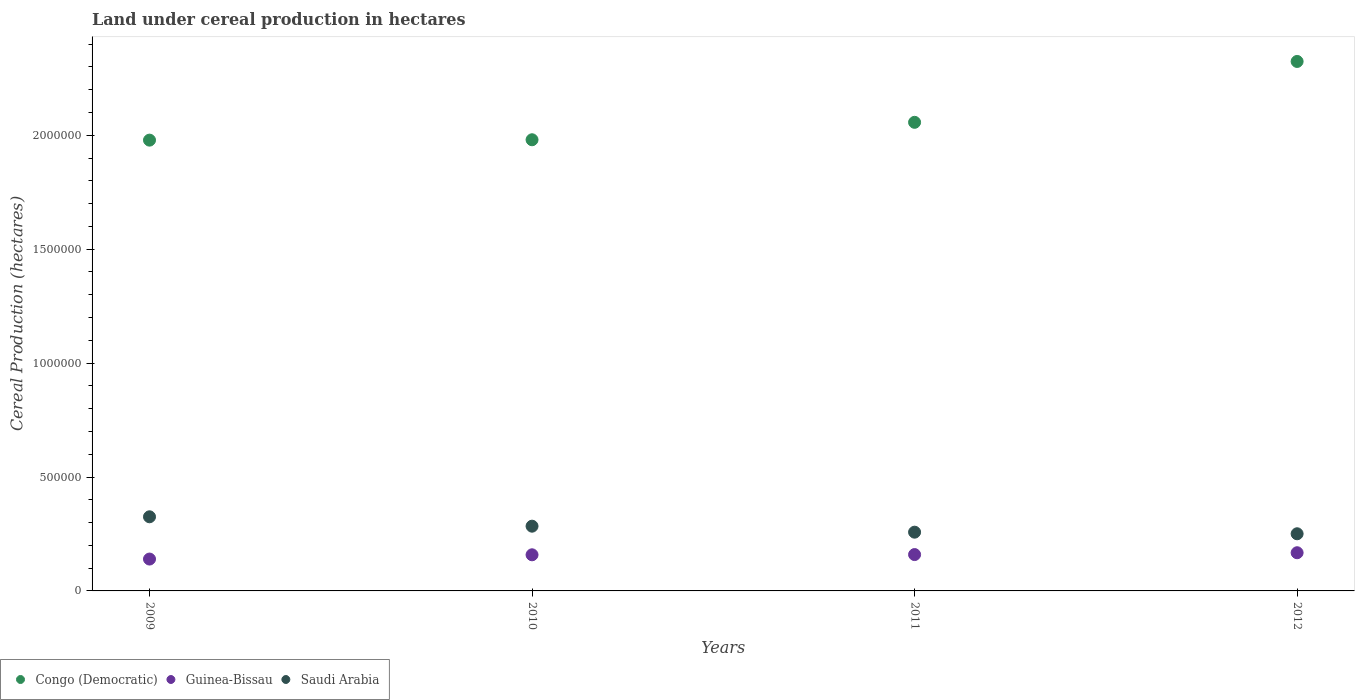Is the number of dotlines equal to the number of legend labels?
Make the answer very short. Yes. What is the land under cereal production in Congo (Democratic) in 2009?
Your response must be concise. 1.98e+06. Across all years, what is the maximum land under cereal production in Saudi Arabia?
Your response must be concise. 3.25e+05. Across all years, what is the minimum land under cereal production in Guinea-Bissau?
Your response must be concise. 1.40e+05. What is the total land under cereal production in Congo (Democratic) in the graph?
Make the answer very short. 8.34e+06. What is the difference between the land under cereal production in Congo (Democratic) in 2010 and that in 2012?
Your response must be concise. -3.44e+05. What is the difference between the land under cereal production in Congo (Democratic) in 2011 and the land under cereal production in Saudi Arabia in 2010?
Provide a succinct answer. 1.77e+06. What is the average land under cereal production in Guinea-Bissau per year?
Offer a terse response. 1.56e+05. In the year 2011, what is the difference between the land under cereal production in Guinea-Bissau and land under cereal production in Saudi Arabia?
Keep it short and to the point. -9.83e+04. What is the ratio of the land under cereal production in Guinea-Bissau in 2011 to that in 2012?
Your answer should be compact. 0.95. What is the difference between the highest and the second highest land under cereal production in Saudi Arabia?
Give a very brief answer. 4.12e+04. What is the difference between the highest and the lowest land under cereal production in Congo (Democratic)?
Offer a terse response. 3.45e+05. In how many years, is the land under cereal production in Saudi Arabia greater than the average land under cereal production in Saudi Arabia taken over all years?
Ensure brevity in your answer.  2. Is the sum of the land under cereal production in Congo (Democratic) in 2010 and 2012 greater than the maximum land under cereal production in Saudi Arabia across all years?
Your answer should be very brief. Yes. Does the land under cereal production in Congo (Democratic) monotonically increase over the years?
Give a very brief answer. Yes. How many dotlines are there?
Ensure brevity in your answer.  3. Are the values on the major ticks of Y-axis written in scientific E-notation?
Provide a succinct answer. No. Does the graph contain grids?
Offer a terse response. No. Where does the legend appear in the graph?
Ensure brevity in your answer.  Bottom left. How are the legend labels stacked?
Offer a terse response. Horizontal. What is the title of the graph?
Your answer should be very brief. Land under cereal production in hectares. Does "Cyprus" appear as one of the legend labels in the graph?
Ensure brevity in your answer.  No. What is the label or title of the Y-axis?
Give a very brief answer. Cereal Production (hectares). What is the Cereal Production (hectares) in Congo (Democratic) in 2009?
Provide a short and direct response. 1.98e+06. What is the Cereal Production (hectares) of Guinea-Bissau in 2009?
Make the answer very short. 1.40e+05. What is the Cereal Production (hectares) in Saudi Arabia in 2009?
Your answer should be compact. 3.25e+05. What is the Cereal Production (hectares) of Congo (Democratic) in 2010?
Ensure brevity in your answer.  1.98e+06. What is the Cereal Production (hectares) of Guinea-Bissau in 2010?
Offer a terse response. 1.59e+05. What is the Cereal Production (hectares) in Saudi Arabia in 2010?
Offer a terse response. 2.84e+05. What is the Cereal Production (hectares) of Congo (Democratic) in 2011?
Give a very brief answer. 2.06e+06. What is the Cereal Production (hectares) in Guinea-Bissau in 2011?
Offer a terse response. 1.60e+05. What is the Cereal Production (hectares) in Saudi Arabia in 2011?
Offer a very short reply. 2.58e+05. What is the Cereal Production (hectares) of Congo (Democratic) in 2012?
Your answer should be compact. 2.32e+06. What is the Cereal Production (hectares) in Guinea-Bissau in 2012?
Ensure brevity in your answer.  1.68e+05. What is the Cereal Production (hectares) of Saudi Arabia in 2012?
Keep it short and to the point. 2.51e+05. Across all years, what is the maximum Cereal Production (hectares) in Congo (Democratic)?
Provide a succinct answer. 2.32e+06. Across all years, what is the maximum Cereal Production (hectares) in Guinea-Bissau?
Give a very brief answer. 1.68e+05. Across all years, what is the maximum Cereal Production (hectares) of Saudi Arabia?
Offer a very short reply. 3.25e+05. Across all years, what is the minimum Cereal Production (hectares) in Congo (Democratic)?
Offer a terse response. 1.98e+06. Across all years, what is the minimum Cereal Production (hectares) of Guinea-Bissau?
Ensure brevity in your answer.  1.40e+05. Across all years, what is the minimum Cereal Production (hectares) of Saudi Arabia?
Make the answer very short. 2.51e+05. What is the total Cereal Production (hectares) of Congo (Democratic) in the graph?
Keep it short and to the point. 8.34e+06. What is the total Cereal Production (hectares) in Guinea-Bissau in the graph?
Make the answer very short. 6.26e+05. What is the total Cereal Production (hectares) of Saudi Arabia in the graph?
Provide a succinct answer. 1.12e+06. What is the difference between the Cereal Production (hectares) in Congo (Democratic) in 2009 and that in 2010?
Your answer should be compact. -1632. What is the difference between the Cereal Production (hectares) of Guinea-Bissau in 2009 and that in 2010?
Give a very brief answer. -1.87e+04. What is the difference between the Cereal Production (hectares) in Saudi Arabia in 2009 and that in 2010?
Offer a terse response. 4.12e+04. What is the difference between the Cereal Production (hectares) of Congo (Democratic) in 2009 and that in 2011?
Your answer should be compact. -7.82e+04. What is the difference between the Cereal Production (hectares) in Guinea-Bissau in 2009 and that in 2011?
Ensure brevity in your answer.  -1.97e+04. What is the difference between the Cereal Production (hectares) in Saudi Arabia in 2009 and that in 2011?
Give a very brief answer. 6.75e+04. What is the difference between the Cereal Production (hectares) of Congo (Democratic) in 2009 and that in 2012?
Ensure brevity in your answer.  -3.45e+05. What is the difference between the Cereal Production (hectares) in Guinea-Bissau in 2009 and that in 2012?
Ensure brevity in your answer.  -2.78e+04. What is the difference between the Cereal Production (hectares) of Saudi Arabia in 2009 and that in 2012?
Ensure brevity in your answer.  7.45e+04. What is the difference between the Cereal Production (hectares) in Congo (Democratic) in 2010 and that in 2011?
Offer a terse response. -7.66e+04. What is the difference between the Cereal Production (hectares) of Guinea-Bissau in 2010 and that in 2011?
Make the answer very short. -995. What is the difference between the Cereal Production (hectares) in Saudi Arabia in 2010 and that in 2011?
Give a very brief answer. 2.63e+04. What is the difference between the Cereal Production (hectares) in Congo (Democratic) in 2010 and that in 2012?
Provide a succinct answer. -3.44e+05. What is the difference between the Cereal Production (hectares) of Guinea-Bissau in 2010 and that in 2012?
Keep it short and to the point. -9051. What is the difference between the Cereal Production (hectares) of Saudi Arabia in 2010 and that in 2012?
Offer a very short reply. 3.33e+04. What is the difference between the Cereal Production (hectares) in Congo (Democratic) in 2011 and that in 2012?
Your answer should be very brief. -2.67e+05. What is the difference between the Cereal Production (hectares) in Guinea-Bissau in 2011 and that in 2012?
Give a very brief answer. -8056. What is the difference between the Cereal Production (hectares) of Saudi Arabia in 2011 and that in 2012?
Keep it short and to the point. 7025. What is the difference between the Cereal Production (hectares) in Congo (Democratic) in 2009 and the Cereal Production (hectares) in Guinea-Bissau in 2010?
Provide a succinct answer. 1.82e+06. What is the difference between the Cereal Production (hectares) of Congo (Democratic) in 2009 and the Cereal Production (hectares) of Saudi Arabia in 2010?
Ensure brevity in your answer.  1.69e+06. What is the difference between the Cereal Production (hectares) of Guinea-Bissau in 2009 and the Cereal Production (hectares) of Saudi Arabia in 2010?
Give a very brief answer. -1.44e+05. What is the difference between the Cereal Production (hectares) of Congo (Democratic) in 2009 and the Cereal Production (hectares) of Guinea-Bissau in 2011?
Offer a very short reply. 1.82e+06. What is the difference between the Cereal Production (hectares) in Congo (Democratic) in 2009 and the Cereal Production (hectares) in Saudi Arabia in 2011?
Give a very brief answer. 1.72e+06. What is the difference between the Cereal Production (hectares) of Guinea-Bissau in 2009 and the Cereal Production (hectares) of Saudi Arabia in 2011?
Ensure brevity in your answer.  -1.18e+05. What is the difference between the Cereal Production (hectares) of Congo (Democratic) in 2009 and the Cereal Production (hectares) of Guinea-Bissau in 2012?
Offer a terse response. 1.81e+06. What is the difference between the Cereal Production (hectares) of Congo (Democratic) in 2009 and the Cereal Production (hectares) of Saudi Arabia in 2012?
Your answer should be compact. 1.73e+06. What is the difference between the Cereal Production (hectares) in Guinea-Bissau in 2009 and the Cereal Production (hectares) in Saudi Arabia in 2012?
Your answer should be compact. -1.11e+05. What is the difference between the Cereal Production (hectares) of Congo (Democratic) in 2010 and the Cereal Production (hectares) of Guinea-Bissau in 2011?
Provide a succinct answer. 1.82e+06. What is the difference between the Cereal Production (hectares) in Congo (Democratic) in 2010 and the Cereal Production (hectares) in Saudi Arabia in 2011?
Your answer should be very brief. 1.72e+06. What is the difference between the Cereal Production (hectares) in Guinea-Bissau in 2010 and the Cereal Production (hectares) in Saudi Arabia in 2011?
Make the answer very short. -9.93e+04. What is the difference between the Cereal Production (hectares) of Congo (Democratic) in 2010 and the Cereal Production (hectares) of Guinea-Bissau in 2012?
Offer a terse response. 1.81e+06. What is the difference between the Cereal Production (hectares) of Congo (Democratic) in 2010 and the Cereal Production (hectares) of Saudi Arabia in 2012?
Your answer should be very brief. 1.73e+06. What is the difference between the Cereal Production (hectares) of Guinea-Bissau in 2010 and the Cereal Production (hectares) of Saudi Arabia in 2012?
Your response must be concise. -9.23e+04. What is the difference between the Cereal Production (hectares) in Congo (Democratic) in 2011 and the Cereal Production (hectares) in Guinea-Bissau in 2012?
Provide a short and direct response. 1.89e+06. What is the difference between the Cereal Production (hectares) in Congo (Democratic) in 2011 and the Cereal Production (hectares) in Saudi Arabia in 2012?
Your answer should be compact. 1.81e+06. What is the difference between the Cereal Production (hectares) in Guinea-Bissau in 2011 and the Cereal Production (hectares) in Saudi Arabia in 2012?
Give a very brief answer. -9.13e+04. What is the average Cereal Production (hectares) of Congo (Democratic) per year?
Your answer should be very brief. 2.09e+06. What is the average Cereal Production (hectares) in Guinea-Bissau per year?
Your response must be concise. 1.56e+05. What is the average Cereal Production (hectares) of Saudi Arabia per year?
Ensure brevity in your answer.  2.80e+05. In the year 2009, what is the difference between the Cereal Production (hectares) of Congo (Democratic) and Cereal Production (hectares) of Guinea-Bissau?
Offer a very short reply. 1.84e+06. In the year 2009, what is the difference between the Cereal Production (hectares) of Congo (Democratic) and Cereal Production (hectares) of Saudi Arabia?
Your response must be concise. 1.65e+06. In the year 2009, what is the difference between the Cereal Production (hectares) in Guinea-Bissau and Cereal Production (hectares) in Saudi Arabia?
Provide a short and direct response. -1.86e+05. In the year 2010, what is the difference between the Cereal Production (hectares) in Congo (Democratic) and Cereal Production (hectares) in Guinea-Bissau?
Make the answer very short. 1.82e+06. In the year 2010, what is the difference between the Cereal Production (hectares) in Congo (Democratic) and Cereal Production (hectares) in Saudi Arabia?
Your answer should be compact. 1.70e+06. In the year 2010, what is the difference between the Cereal Production (hectares) in Guinea-Bissau and Cereal Production (hectares) in Saudi Arabia?
Keep it short and to the point. -1.26e+05. In the year 2011, what is the difference between the Cereal Production (hectares) in Congo (Democratic) and Cereal Production (hectares) in Guinea-Bissau?
Keep it short and to the point. 1.90e+06. In the year 2011, what is the difference between the Cereal Production (hectares) of Congo (Democratic) and Cereal Production (hectares) of Saudi Arabia?
Your response must be concise. 1.80e+06. In the year 2011, what is the difference between the Cereal Production (hectares) in Guinea-Bissau and Cereal Production (hectares) in Saudi Arabia?
Provide a short and direct response. -9.83e+04. In the year 2012, what is the difference between the Cereal Production (hectares) in Congo (Democratic) and Cereal Production (hectares) in Guinea-Bissau?
Your answer should be very brief. 2.16e+06. In the year 2012, what is the difference between the Cereal Production (hectares) in Congo (Democratic) and Cereal Production (hectares) in Saudi Arabia?
Keep it short and to the point. 2.07e+06. In the year 2012, what is the difference between the Cereal Production (hectares) of Guinea-Bissau and Cereal Production (hectares) of Saudi Arabia?
Ensure brevity in your answer.  -8.32e+04. What is the ratio of the Cereal Production (hectares) of Congo (Democratic) in 2009 to that in 2010?
Your answer should be compact. 1. What is the ratio of the Cereal Production (hectares) of Guinea-Bissau in 2009 to that in 2010?
Your answer should be very brief. 0.88. What is the ratio of the Cereal Production (hectares) of Saudi Arabia in 2009 to that in 2010?
Keep it short and to the point. 1.15. What is the ratio of the Cereal Production (hectares) in Congo (Democratic) in 2009 to that in 2011?
Make the answer very short. 0.96. What is the ratio of the Cereal Production (hectares) of Guinea-Bissau in 2009 to that in 2011?
Provide a short and direct response. 0.88. What is the ratio of the Cereal Production (hectares) of Saudi Arabia in 2009 to that in 2011?
Offer a very short reply. 1.26. What is the ratio of the Cereal Production (hectares) in Congo (Democratic) in 2009 to that in 2012?
Your answer should be compact. 0.85. What is the ratio of the Cereal Production (hectares) of Guinea-Bissau in 2009 to that in 2012?
Make the answer very short. 0.83. What is the ratio of the Cereal Production (hectares) of Saudi Arabia in 2009 to that in 2012?
Provide a succinct answer. 1.3. What is the ratio of the Cereal Production (hectares) of Congo (Democratic) in 2010 to that in 2011?
Your answer should be very brief. 0.96. What is the ratio of the Cereal Production (hectares) of Guinea-Bissau in 2010 to that in 2011?
Provide a short and direct response. 0.99. What is the ratio of the Cereal Production (hectares) of Saudi Arabia in 2010 to that in 2011?
Your response must be concise. 1.1. What is the ratio of the Cereal Production (hectares) in Congo (Democratic) in 2010 to that in 2012?
Make the answer very short. 0.85. What is the ratio of the Cereal Production (hectares) in Guinea-Bissau in 2010 to that in 2012?
Your response must be concise. 0.95. What is the ratio of the Cereal Production (hectares) in Saudi Arabia in 2010 to that in 2012?
Provide a succinct answer. 1.13. What is the ratio of the Cereal Production (hectares) of Congo (Democratic) in 2011 to that in 2012?
Your answer should be very brief. 0.89. What is the ratio of the Cereal Production (hectares) of Guinea-Bissau in 2011 to that in 2012?
Your response must be concise. 0.95. What is the ratio of the Cereal Production (hectares) in Saudi Arabia in 2011 to that in 2012?
Give a very brief answer. 1.03. What is the difference between the highest and the second highest Cereal Production (hectares) of Congo (Democratic)?
Your answer should be compact. 2.67e+05. What is the difference between the highest and the second highest Cereal Production (hectares) of Guinea-Bissau?
Offer a terse response. 8056. What is the difference between the highest and the second highest Cereal Production (hectares) of Saudi Arabia?
Your answer should be compact. 4.12e+04. What is the difference between the highest and the lowest Cereal Production (hectares) of Congo (Democratic)?
Provide a short and direct response. 3.45e+05. What is the difference between the highest and the lowest Cereal Production (hectares) in Guinea-Bissau?
Your answer should be very brief. 2.78e+04. What is the difference between the highest and the lowest Cereal Production (hectares) of Saudi Arabia?
Your response must be concise. 7.45e+04. 